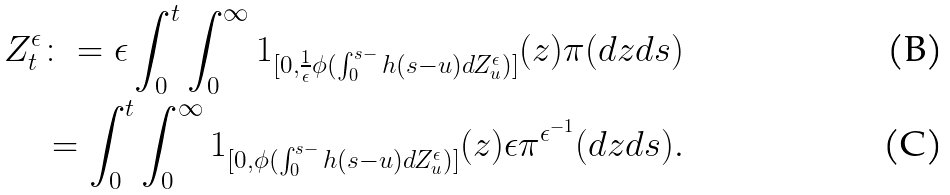<formula> <loc_0><loc_0><loc_500><loc_500>Z _ { t } ^ { \epsilon } & \colon = \epsilon \int _ { 0 } ^ { t } \int _ { 0 } ^ { \infty } 1 _ { [ 0 , \frac { 1 } { \epsilon } \phi ( \int _ { 0 } ^ { s - } h ( s - u ) d Z _ { u } ^ { \epsilon } ) ] } ( z ) \pi ( d z d s ) \\ & = \int _ { 0 } ^ { t } \int _ { 0 } ^ { \infty } 1 _ { [ 0 , \phi ( \int _ { 0 } ^ { s - } h ( s - u ) d Z _ { u } ^ { \epsilon } ) ] } ( z ) \epsilon \pi ^ { \epsilon ^ { - 1 } } ( d z d s ) .</formula> 